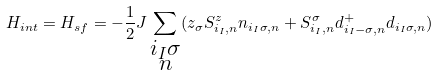Convert formula to latex. <formula><loc_0><loc_0><loc_500><loc_500>H _ { i n t } = H _ { s f } = - \frac { 1 } { 2 } J \sum _ { \substack { i _ { I } \sigma \\ n } } ( z _ { \sigma } S _ { i _ { I } , n } ^ { z } n _ { i _ { I } \sigma , n } + S _ { i _ { I } , n } ^ { \sigma } d _ { i _ { I } - \sigma , n } ^ { + } d _ { i _ { I } \sigma , n } )</formula> 